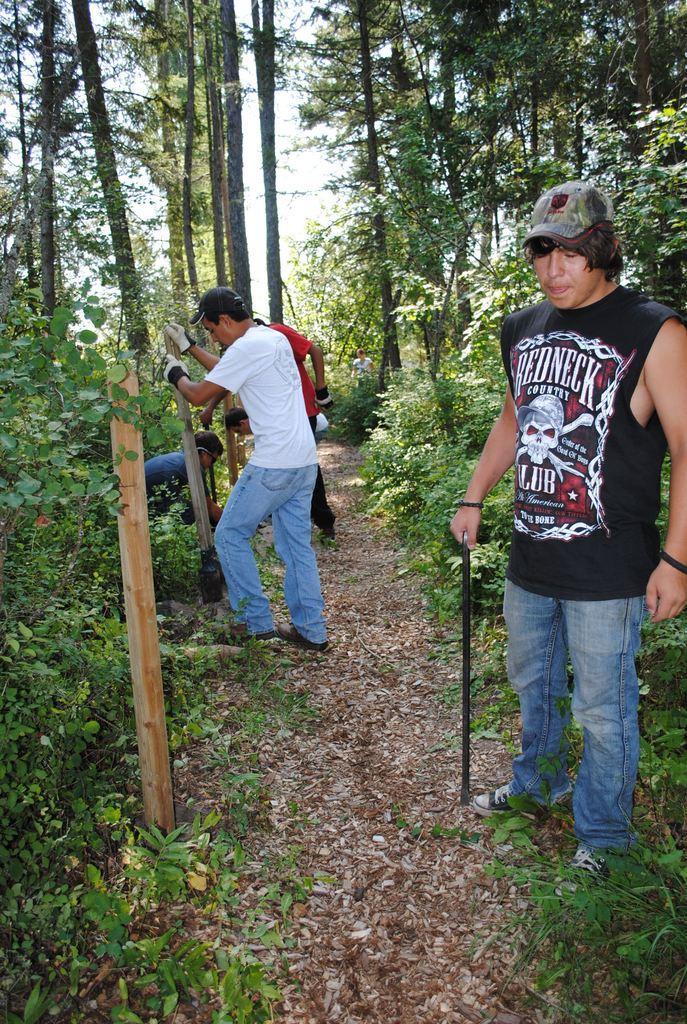Describe this image in one or two sentences. In this picture we can see people standing and erecting wooden poles into the ground surrounded by trees and plants. 